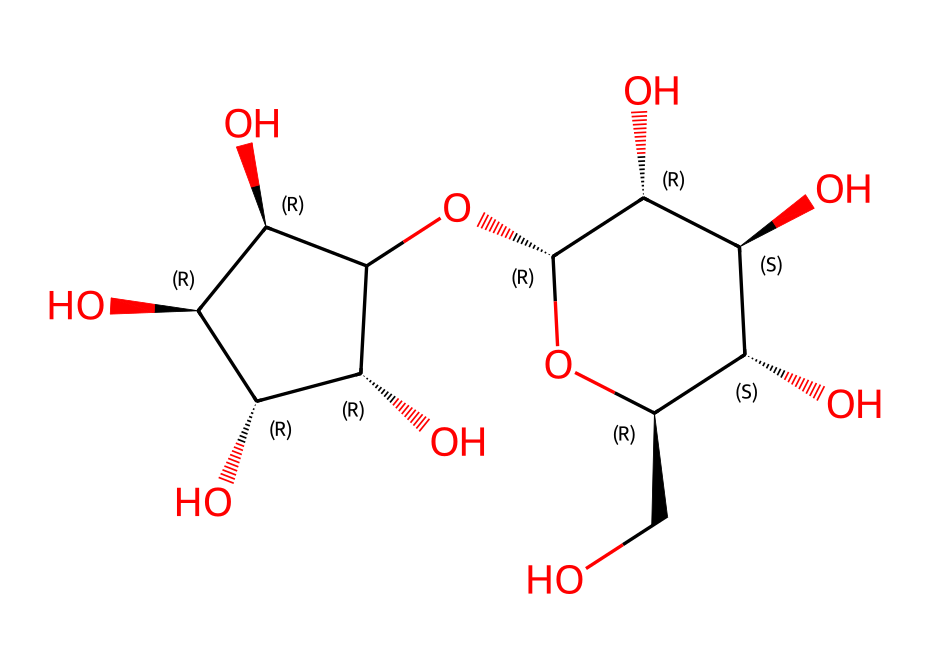What is the name of the main component in oobleck? The provided SMILES representation corresponds to a polysaccharide called cornstarch, which is the primary ingredient in oobleck.
Answer: cornstarch How many carbon atoms are present in oobleck? By analyzing the SMILES string, it can be determined that there are 12 carbon atoms present in the structure of cornstarch in oobleck.
Answer: 12 Which type of bonds are predominantly found in the chemical structure of oobleck? The structure reveals that it is primarily composed of single covalent bonds between the carbon and hydroxyl (OH) groups, which are characteristic of polysaccharides.
Answer: single covalent bonds What is the impact of the hydroxyl groups on the properties of oobleck? The presence of multiple hydroxyl groups contributes to oobleck's ability to interact with water, influencing its viscosity and creating its non-Newtonian behavior when stressed.
Answer: viscosity How does the structure of oobleck enable its non-Newtonian behavior? The arrangement of long polysaccharide chains in cornstarch allows for temporary bonds under stress, causing it to behave as a solid when pressure is applied and a liquid when pressure is released, exemplifying shear-thickening behavior.
Answer: shear-thickening behavior Why is oobleck classified as a non-Newtonian fluid? Oobleck does not have a constant viscosity; instead, its viscosity changes based on the applied stress, which distinguishes it from Newtonian fluids that maintain a constant viscosity regardless of stress.
Answer: non-constant viscosity 